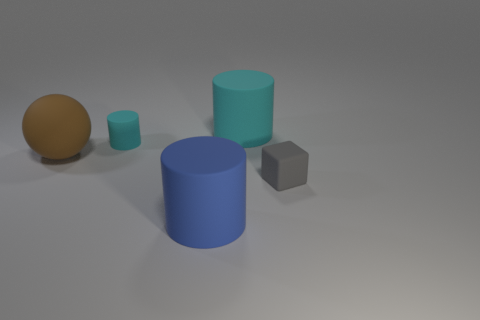Are there any other things that are the same material as the gray block?
Offer a terse response. Yes. The object that is the same color as the tiny matte cylinder is what shape?
Ensure brevity in your answer.  Cylinder. What is the small cyan cylinder made of?
Keep it short and to the point. Rubber. Is the gray block made of the same material as the brown ball?
Keep it short and to the point. Yes. How many shiny objects are blue cylinders or large objects?
Make the answer very short. 0. There is a small thing on the left side of the blue cylinder; what is its shape?
Keep it short and to the point. Cylinder. There is a blue cylinder that is the same material as the cube; what size is it?
Your answer should be compact. Large. The matte thing that is in front of the large sphere and to the left of the gray matte object has what shape?
Make the answer very short. Cylinder. Does the cylinder to the right of the blue cylinder have the same color as the large sphere?
Provide a short and direct response. No. Is the shape of the large cyan object that is to the right of the small cyan thing the same as the large matte object that is in front of the brown matte sphere?
Your answer should be compact. Yes. 